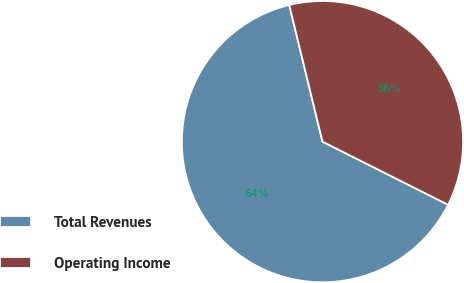Convert chart to OTSL. <chart><loc_0><loc_0><loc_500><loc_500><pie_chart><fcel>Total Revenues<fcel>Operating Income<nl><fcel>63.79%<fcel>36.21%<nl></chart> 